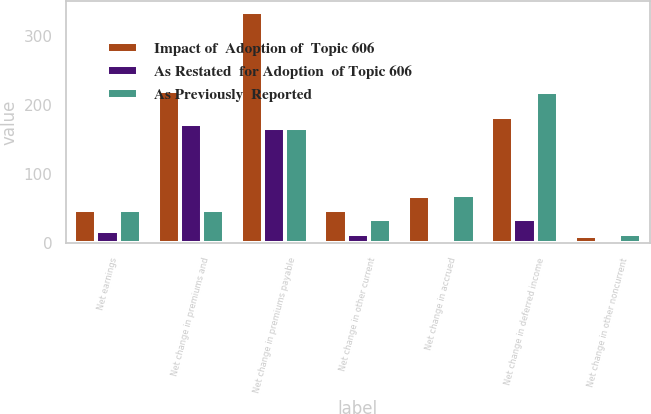Convert chart. <chart><loc_0><loc_0><loc_500><loc_500><stacked_bar_chart><ecel><fcel>Net earnings<fcel>Net change in premiums and<fcel>Net change in premiums payable<fcel>Net change in other current<fcel>Net change in accrued<fcel>Net change in deferred income<fcel>Net change in other noncurrent<nl><fcel>Impact of  Adoption of  Topic 606<fcel>48.5<fcel>220.3<fcel>334.3<fcel>48.5<fcel>69.3<fcel>183.4<fcel>11.1<nl><fcel>As Restated  for Adoption  of Topic 606<fcel>17.7<fcel>172.6<fcel>167.4<fcel>13.2<fcel>0.3<fcel>35.9<fcel>2.1<nl><fcel>As Previously  Reported<fcel>48.5<fcel>47.7<fcel>166.9<fcel>35.3<fcel>69.6<fcel>219.3<fcel>13.2<nl></chart> 